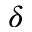Convert formula to latex. <formula><loc_0><loc_0><loc_500><loc_500>\delta</formula> 